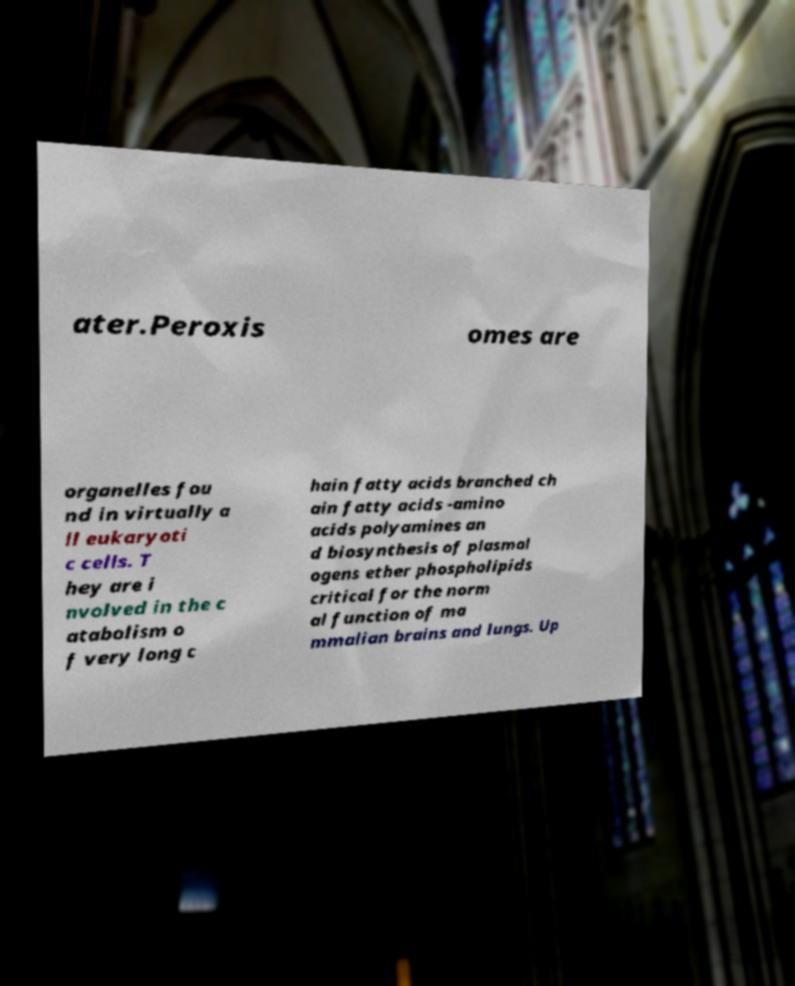I need the written content from this picture converted into text. Can you do that? ater.Peroxis omes are organelles fou nd in virtually a ll eukaryoti c cells. T hey are i nvolved in the c atabolism o f very long c hain fatty acids branched ch ain fatty acids -amino acids polyamines an d biosynthesis of plasmal ogens ether phospholipids critical for the norm al function of ma mmalian brains and lungs. Up 